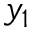<formula> <loc_0><loc_0><loc_500><loc_500>y _ { 1 }</formula> 